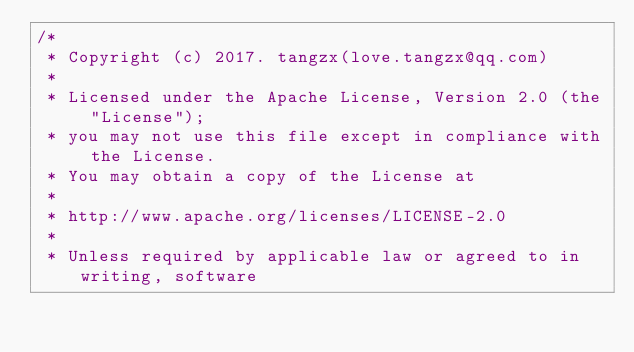<code> <loc_0><loc_0><loc_500><loc_500><_Kotlin_>/*
 * Copyright (c) 2017. tangzx(love.tangzx@qq.com)
 *
 * Licensed under the Apache License, Version 2.0 (the "License");
 * you may not use this file except in compliance with the License.
 * You may obtain a copy of the License at
 *
 * http://www.apache.org/licenses/LICENSE-2.0
 *
 * Unless required by applicable law or agreed to in writing, software</code> 